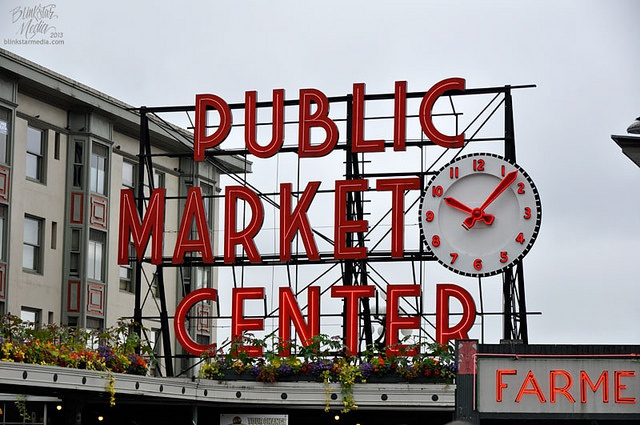Describe the objects in this image and their specific colors. I can see a clock in lightgray, darkgray, gray, black, and red tones in this image. 